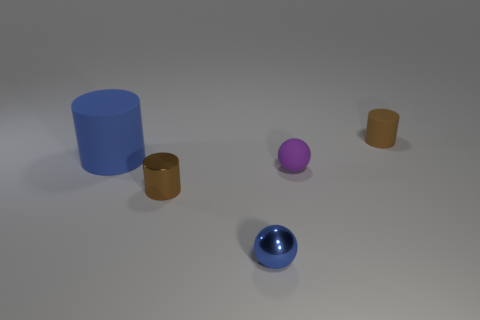The other purple object that is the same material as the large thing is what shape?
Your answer should be very brief. Sphere. There is a blue object in front of the tiny brown cylinder to the left of the small rubber cylinder on the right side of the tiny blue ball; what is its material?
Ensure brevity in your answer.  Metal. What number of things are small cylinders in front of the blue matte cylinder or red rubber spheres?
Your response must be concise. 1. How many other things are there of the same shape as the big thing?
Offer a very short reply. 2. Is the number of rubber cylinders that are on the left side of the brown matte cylinder greater than the number of tiny rubber cylinders?
Keep it short and to the point. No. The blue rubber thing that is the same shape as the small brown metallic object is what size?
Your response must be concise. Large. Are there any other things that have the same material as the large blue cylinder?
Make the answer very short. Yes. What shape is the brown metallic thing?
Offer a terse response. Cylinder. What is the shape of the brown metallic object that is the same size as the blue shiny ball?
Give a very brief answer. Cylinder. Is there anything else of the same color as the big object?
Your response must be concise. Yes. 